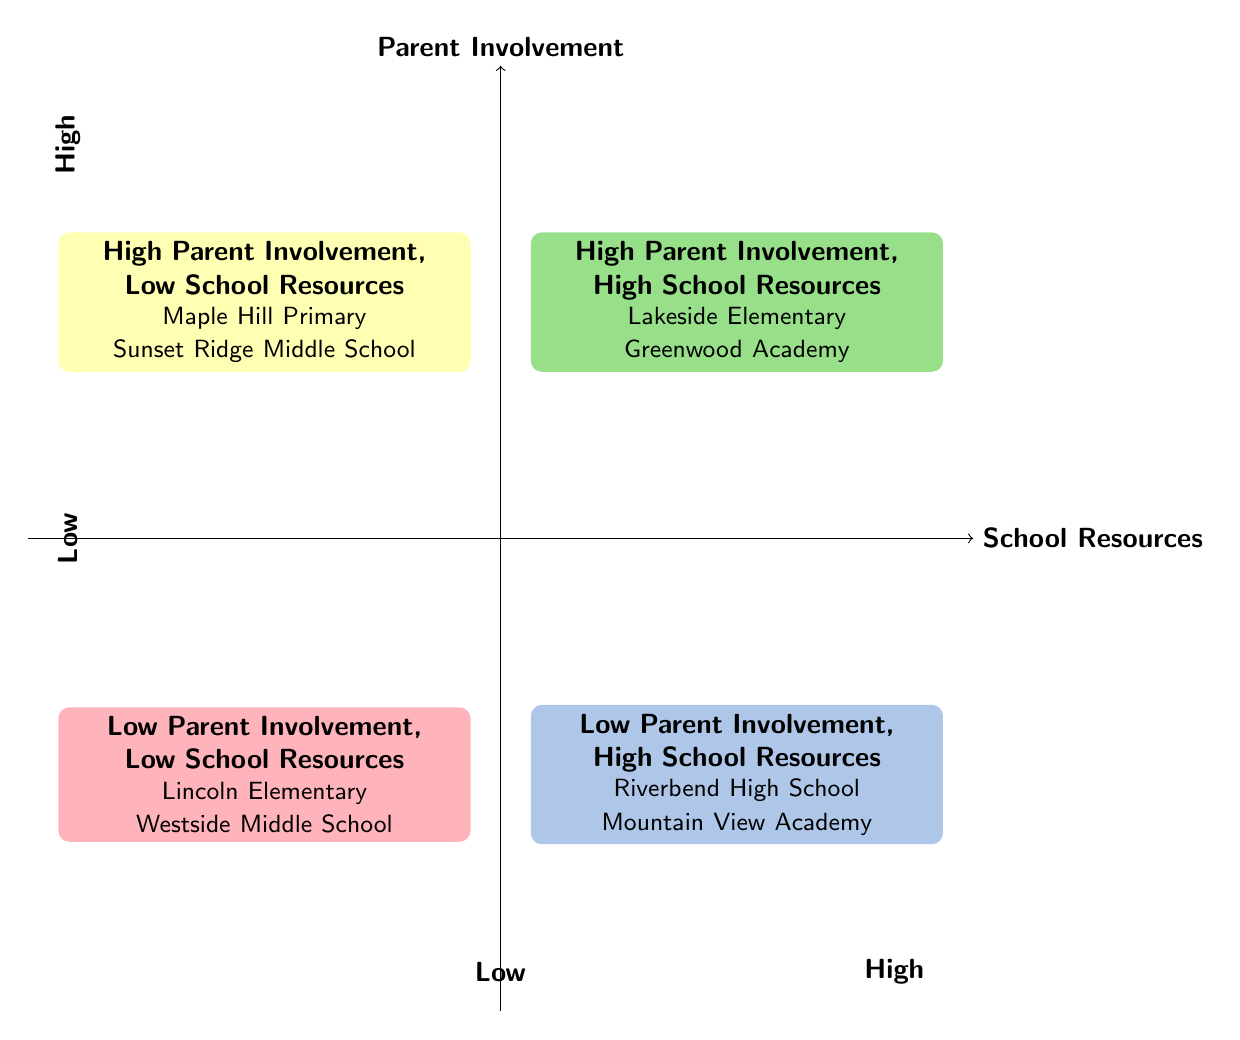What schools are in the High Parent Involvement, High School Resources quadrant? The quadrant lists the schools categorized as having high parent involvement and high resources, specifically Lakeside Elementary and Greenwood Academy.
Answer: Lakeside Elementary, Greenwood Academy How many quadrants are shown in the diagram? The diagram contains four distinct quadrants, each representing a different combination of parent involvement and school resources.
Answer: Four What is the relationship between Low School Resources and High Parent Involvement? The quadrant with High Parent Involvement and Low School Resources indicates that schools can have engaged parents despite limited financial support, illustrated by schools like Maple Hill Primary and Sunset Ridge Middle School.
Answer: Engaged parents Which schools exhibit Low Parent Involvement and Low School Resources? The schools falling under this category are Lincoln Elementary and Westside Middle School, which are cited in the respective quadrant.
Answer: Lincoln Elementary, Westside Middle School Are there any schools with Low Parent Involvement but High School Resources? The diagram specifies that Riverbend High School and Mountain View Academy belong to the Low Parent Involvement, High School Resources quadrant, confirming their categorization.
Answer: Yes How does High Parent Involvement affect the quality of education at schools with Low Resources? The presence of high parental involvement in schools with limited resources can lead to improved educational opportunities despite the lack of funding, as seen in volunteer-led programs and fundraising efforts.
Answer: Improved opportunities What color is used to represent High Parent Involvement, Low School Resources? The quadrant showing this category is colored yellow in the diagram, visually distinguishing it from the others.
Answer: Yellow Which quadrant contains the least favorable conditions for schools? The quadrant labeled Low Parent Involvement, Low School Resources is characterized by the least favorable educational conditions, as it signifies both low engagement and lack of funding.
Answer: Low Parent Involvement, Low School Resources 